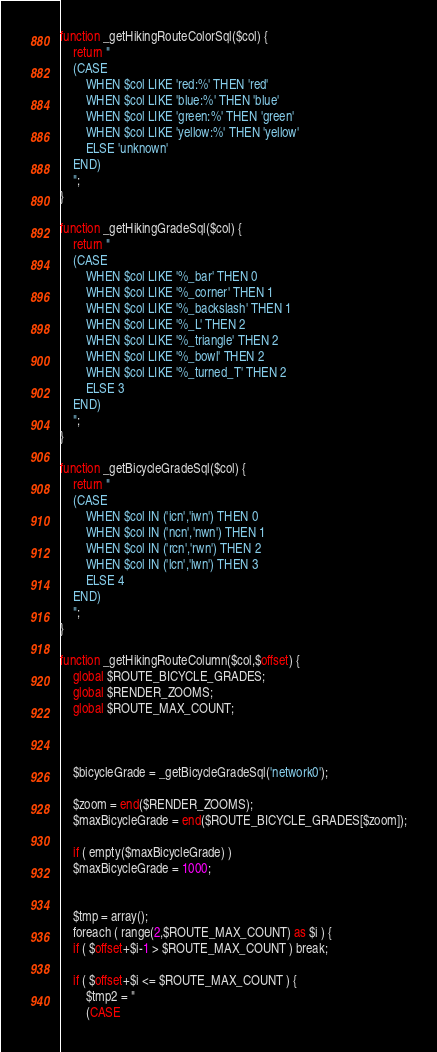<code> <loc_0><loc_0><loc_500><loc_500><_SQL_>function _getHikingRouteColorSql($col) {
    return "
	(CASE
	    WHEN $col LIKE 'red:%' THEN 'red'
	    WHEN $col LIKE 'blue:%' THEN 'blue'
	    WHEN $col LIKE 'green:%' THEN 'green'
	    WHEN $col LIKE 'yellow:%' THEN 'yellow'
	    ELSE 'unknown'
	END)
    ";
}

function _getHikingGradeSql($col) {
    return "
	(CASE
	    WHEN $col LIKE '%_bar' THEN 0
	    WHEN $col LIKE '%_corner' THEN 1
	    WHEN $col LIKE '%_backslash' THEN 1
	    WHEN $col LIKE '%_L' THEN 2
	    WHEN $col LIKE '%_triangle' THEN 2
	    WHEN $col LIKE '%_bowl' THEN 2
	    WHEN $col LIKE '%_turned_T' THEN 2
	    ELSE 3
	END)
    ";
}

function _getBicycleGradeSql($col) {
    return "
	(CASE
	    WHEN $col IN ('icn','iwn') THEN 0
	    WHEN $col IN ('ncn','nwn') THEN 1
	    WHEN $col IN ('rcn','rwn') THEN 2
	    WHEN $col IN ('lcn','lwn') THEN 3	    
	    ELSE 4
	END)
    ";
}

function _getHikingRouteColumn($col,$offset) {
    global $ROUTE_BICYCLE_GRADES;
    global $RENDER_ZOOMS;
    global $ROUTE_MAX_COUNT;
    
    
    
    $bicycleGrade = _getBicycleGradeSql('network0');
    
    $zoom = end($RENDER_ZOOMS);
    $maxBicycleGrade = end($ROUTE_BICYCLE_GRADES[$zoom]);
    
    if ( empty($maxBicycleGrade) )
	$maxBicycleGrade = 1000;
    
    
    $tmp = array();
    foreach ( range(2,$ROUTE_MAX_COUNT) as $i ) {
	if ( $offset+$i-1 > $ROUTE_MAX_COUNT ) break;
	
	if ( $offset+$i <= $ROUTE_MAX_COUNT ) {
	    $tmp2 = "
		(CASE</code> 